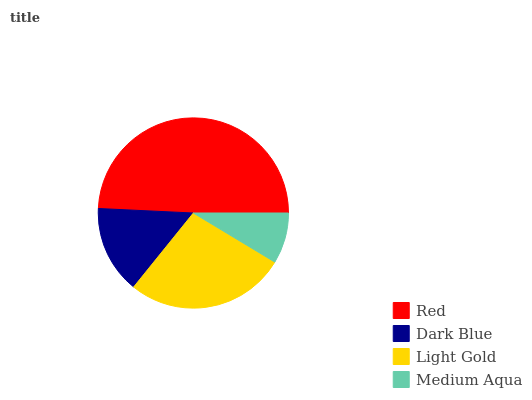Is Medium Aqua the minimum?
Answer yes or no. Yes. Is Red the maximum?
Answer yes or no. Yes. Is Dark Blue the minimum?
Answer yes or no. No. Is Dark Blue the maximum?
Answer yes or no. No. Is Red greater than Dark Blue?
Answer yes or no. Yes. Is Dark Blue less than Red?
Answer yes or no. Yes. Is Dark Blue greater than Red?
Answer yes or no. No. Is Red less than Dark Blue?
Answer yes or no. No. Is Light Gold the high median?
Answer yes or no. Yes. Is Dark Blue the low median?
Answer yes or no. Yes. Is Dark Blue the high median?
Answer yes or no. No. Is Light Gold the low median?
Answer yes or no. No. 